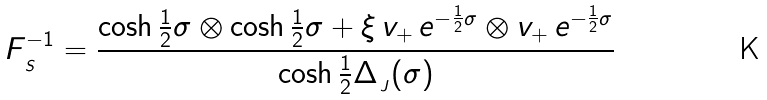Convert formula to latex. <formula><loc_0><loc_0><loc_500><loc_500>F _ { _ { \, S } } ^ { - 1 } = \frac { \cosh \frac { 1 } { 2 } \sigma \otimes \cosh \frac { 1 } { 2 } \sigma + \xi \, v _ { + } \, e ^ { - \frac { 1 } { 2 } \sigma } \otimes v _ { + } \, e ^ { - \frac { 1 } { 2 } \sigma } } { \cosh \frac { 1 } { 2 } \Delta _ { _ { \, J } } ( \sigma ) } \,</formula> 